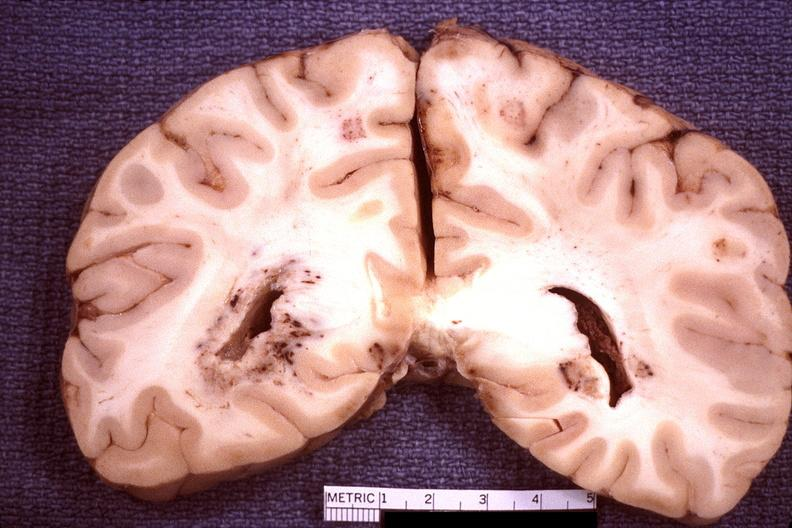s nervous present?
Answer the question using a single word or phrase. Yes 